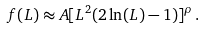<formula> <loc_0><loc_0><loc_500><loc_500>f ( L ) \approx A [ L ^ { 2 } ( 2 \ln ( L ) - 1 ) ] ^ { \rho } \, .</formula> 